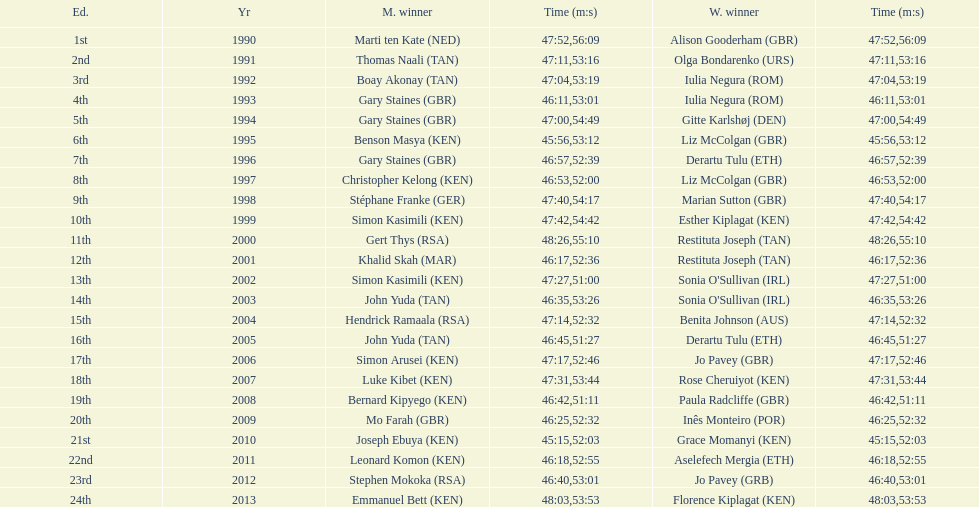The other women's winner with the same finish time as jo pavey in 2012 Iulia Negura. 